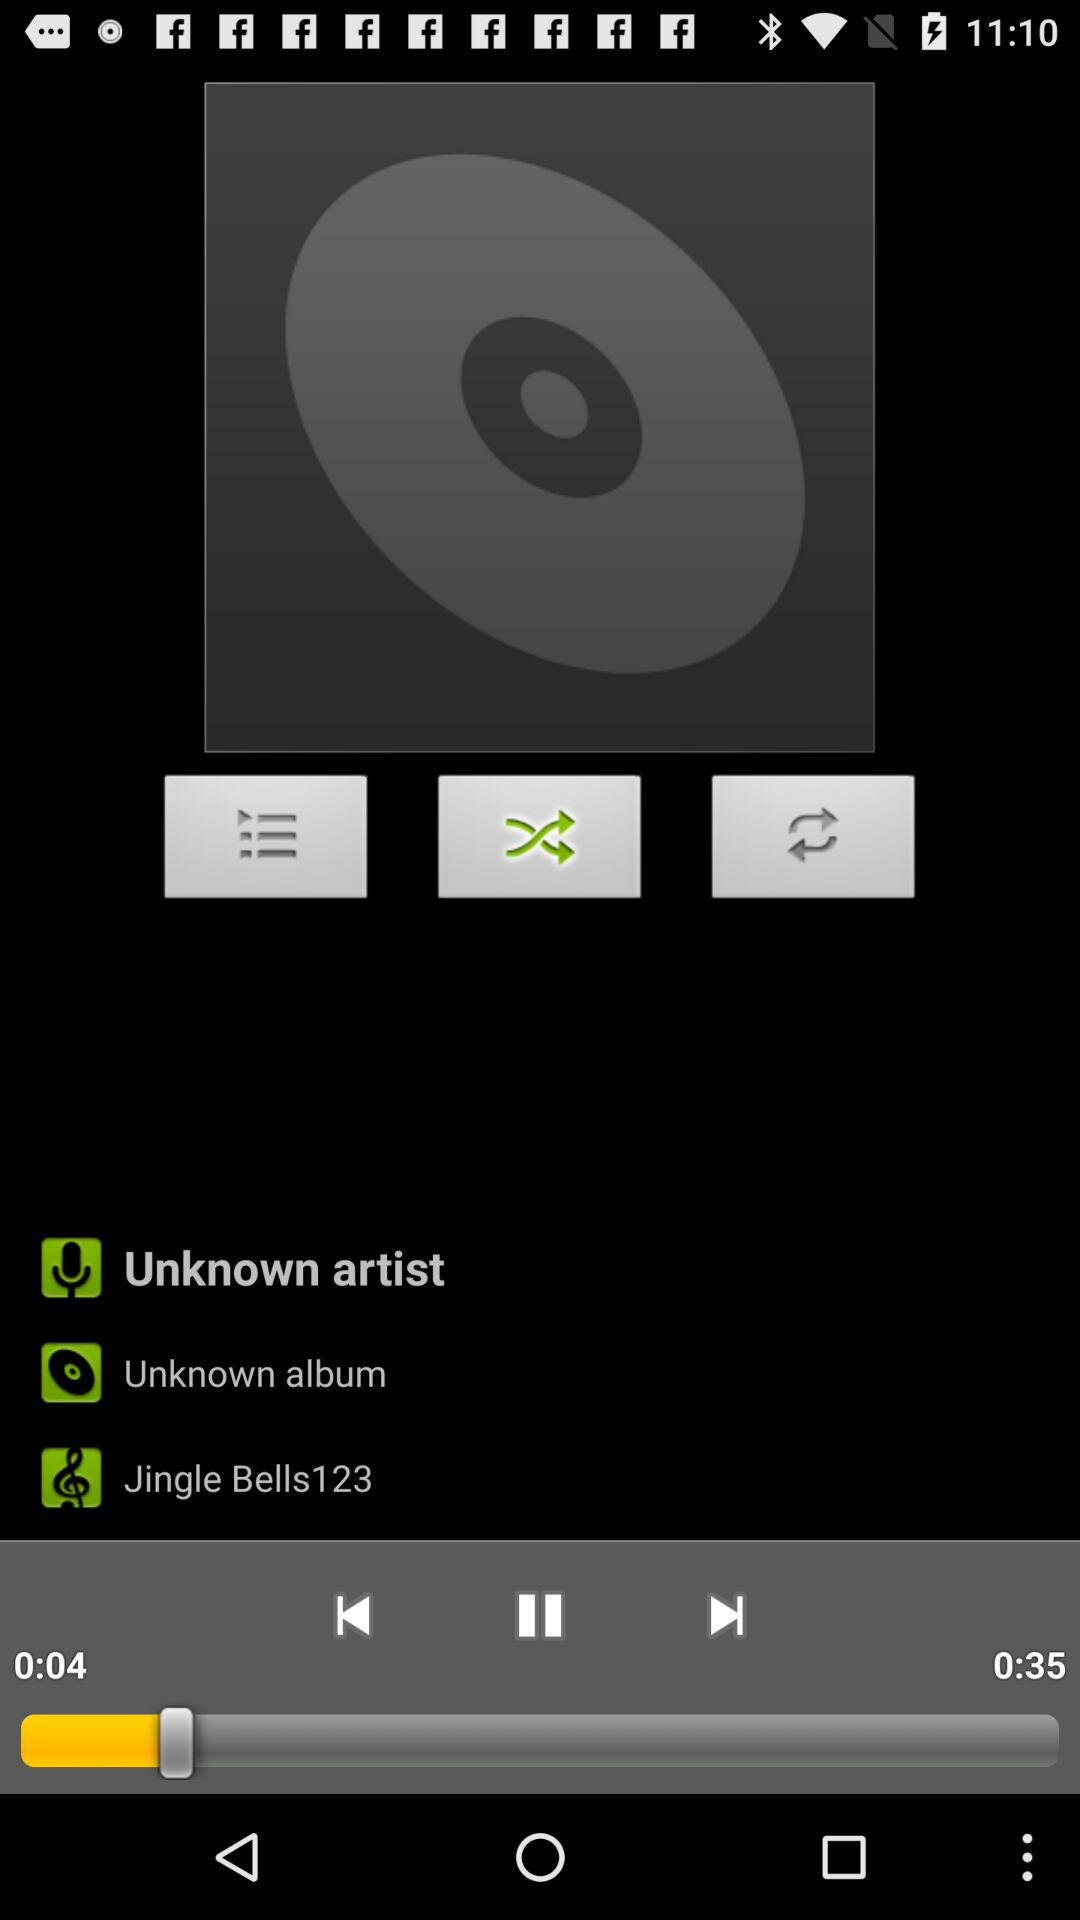What's the total duration? The total duration is 35 seconds. 